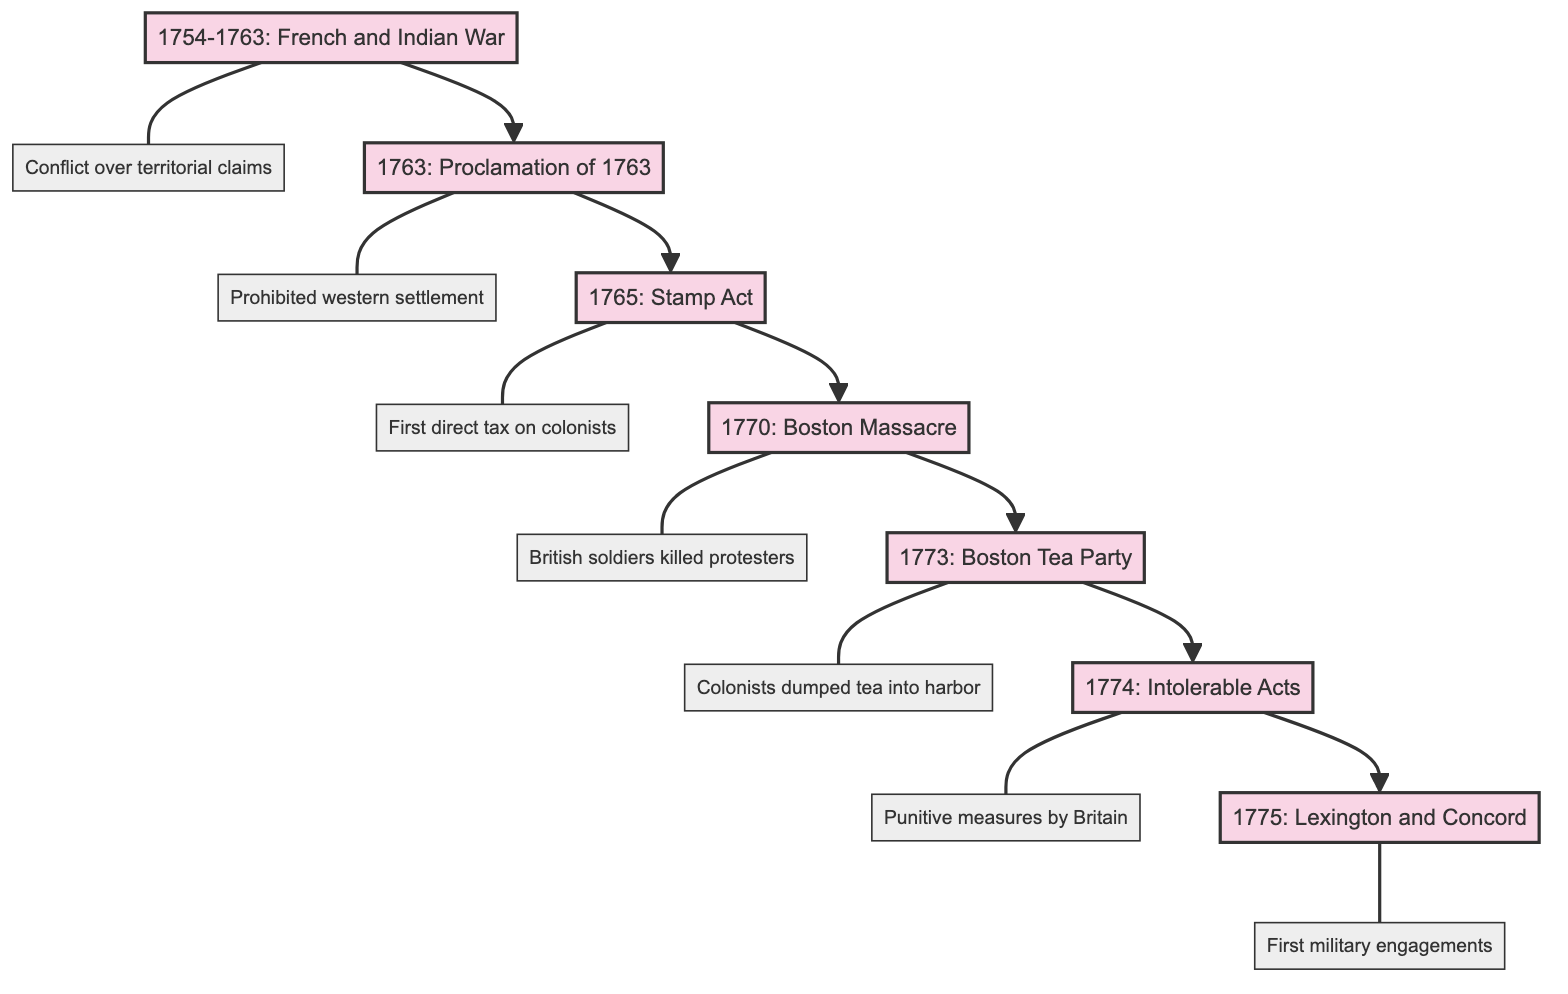What is the first event listed in the diagram? The diagram starts with the event titled "1754-1763: French and Indian War," which is the first node.
Answer: 1754-1763: French and Indian War How many events are shown in the diagram? The diagram includes a total of seven distinct events, starting from the French and Indian War and ending with the Battles of Lexington and Concord.
Answer: 7 Which event follows the Boston Massacre in the flow? According to the flow of the diagram, the event that comes directly after the Boston Massacre is the Boston Tea Party, which is the next node connected in the sequence.
Answer: 1773: Boston Tea Party What was the purpose of the Stamp Act? The diagram indicates that the purpose of the Stamp Act was to impose the first direct tax on American colonists, aiming to raise revenue for British debt, situated beneath the node for this event.
Answer: First direct tax on American colonists What event prompted the Intolerable Acts? The diagram clearly connects the Boston Tea Party to the Intolerable Acts, indicating that this act of protest led directly to the series of punitive measures enacted by Britain.
Answer: Boston Tea Party What was the result of the Battles of Lexington and Concord? The final node in this flowchart states that the Battles of Lexington and Concord marked the first military engagements of the American Revolutionary War, summarizing the significance of these events in the overall timeline.
Answer: First military engagements What was prohibited by the Proclamation of 1763? Under the Proclamation of 1763 node, it is explicitly stated that it prohibited colonial settlement west of the Appalachian Mountains, directly answering what the proclamation entailed.
Answer: Prohibited colonial settlement west of the Appalachian Mountains What connects the first event to the second event in the diagram? The diagram illustrates a direct flow from the first event, the French and Indian War, to the second event, the Proclamation of 1763, showing that each event leads into the next in the timeline of events leading up to the American Revolution.
Answer: Flow/Connection What type of conflict was the French and Indian War? The description provided in the diagram for the French and Indian War characterizes it as a conflict over territorial claims, specifically between Britain and France in North America, which describes the nature of the war.
Answer: Conflict over territorial claims 